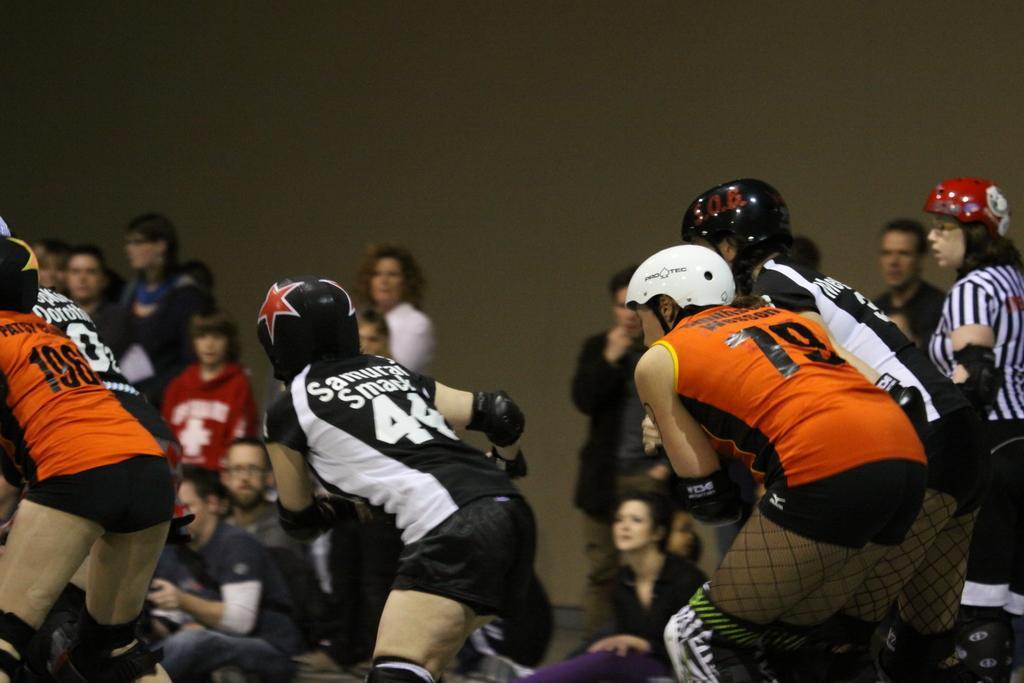Could you give a brief overview of what you see in this image? In this picture there are four girls wearing orange, white and black t- shirts with helmet on the head playing the game. Behind there is a group of audience watching the game. 